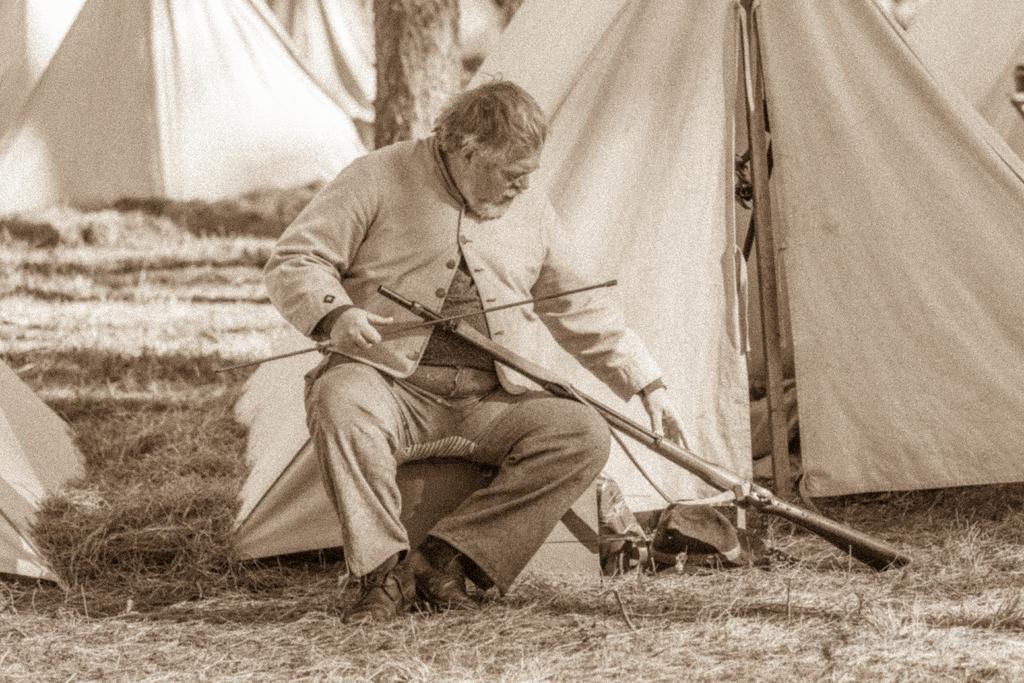Describe this image in one or two sentences. In this image I can see a person wearing jacket, pant and footwear is sitting and holding a stick and a weapon in his hand. In the background I can see some grass, few trees and few tents. 